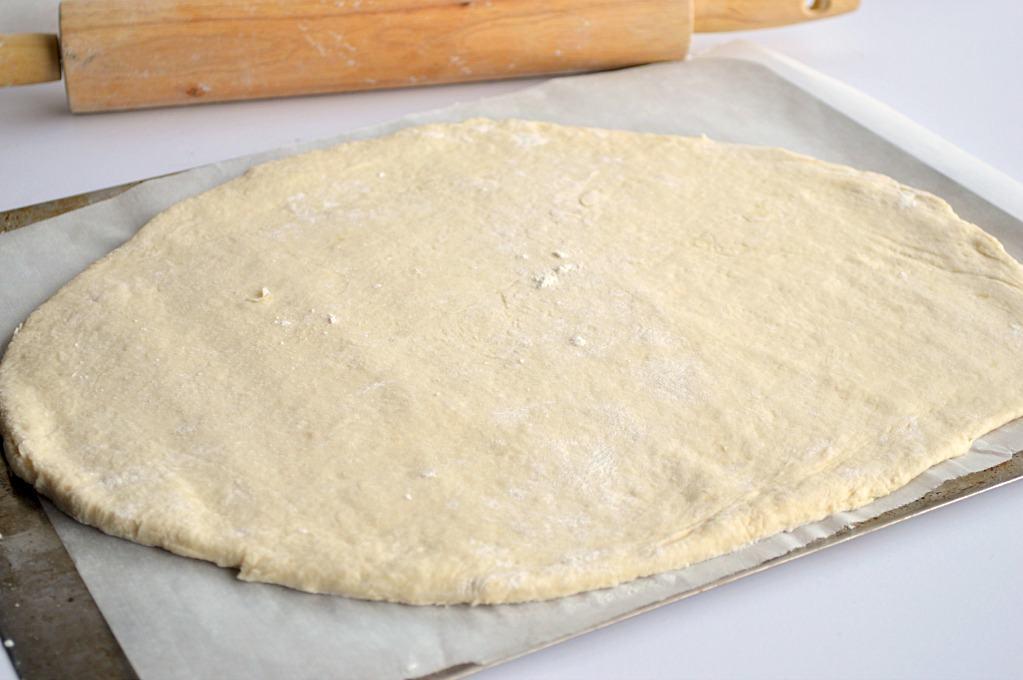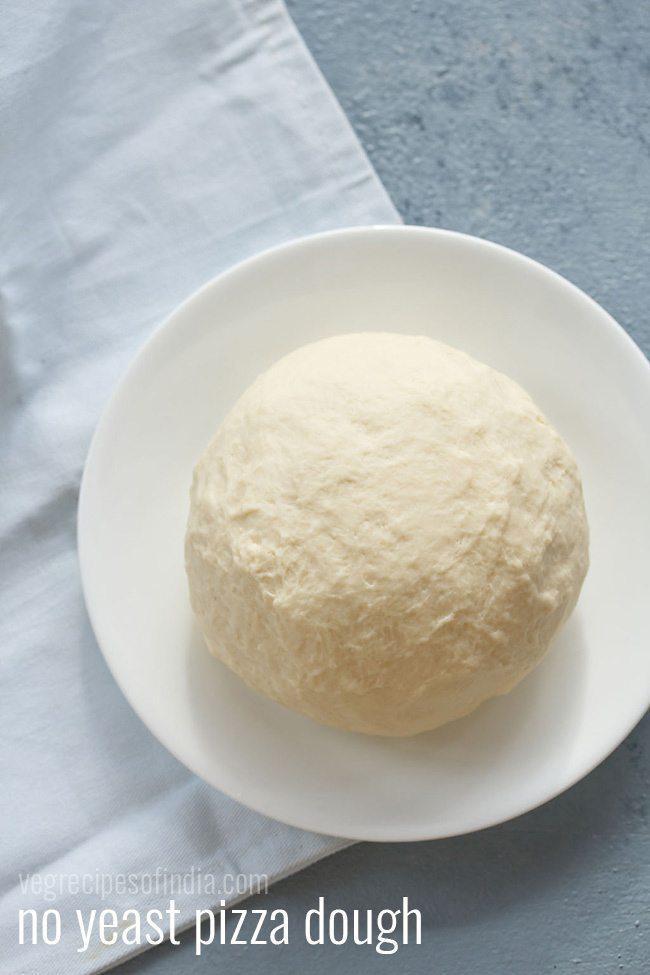The first image is the image on the left, the second image is the image on the right. Examine the images to the left and right. Is the description "In one image the dough has been rolled." accurate? Answer yes or no. Yes. The first image is the image on the left, the second image is the image on the right. Given the left and right images, does the statement "One image shows a round ball of dough on a white plate that rests on a white cloth, and the other image shows a flattened round dough shape." hold true? Answer yes or no. Yes. 